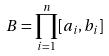Convert formula to latex. <formula><loc_0><loc_0><loc_500><loc_500>B = \prod _ { i = 1 } ^ { n } [ a _ { i } , b _ { i } ]</formula> 